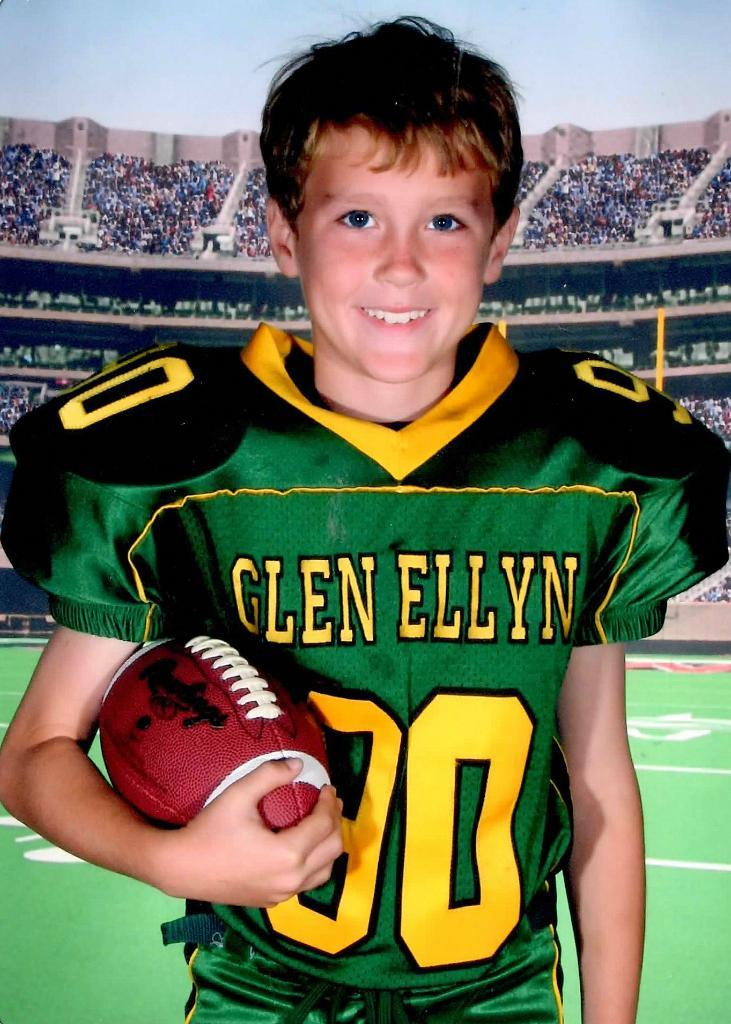<image>
Offer a succinct explanation of the picture presented. A child with a green jersey that has the name Glen Ellyn on it 